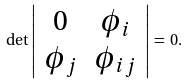<formula> <loc_0><loc_0><loc_500><loc_500>\det \left | \begin{array} { c c } 0 & \phi _ { i } \\ \phi _ { j } & \phi _ { i j } \end{array} \right | \, = \, 0 .</formula> 